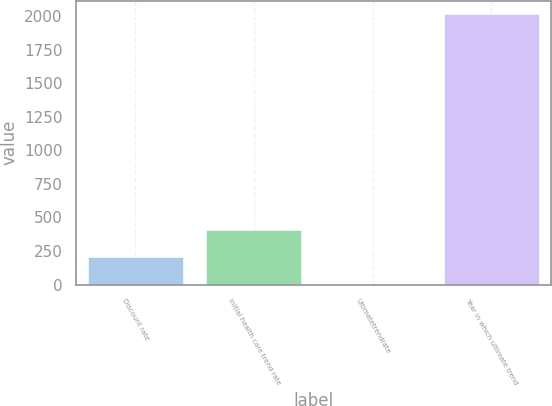<chart> <loc_0><loc_0><loc_500><loc_500><bar_chart><fcel>Discount rate<fcel>Initial health care trend rate<fcel>Ultimatetrendrate<fcel>Year in which ultimate trend<nl><fcel>205.35<fcel>406.2<fcel>4.5<fcel>2013<nl></chart> 